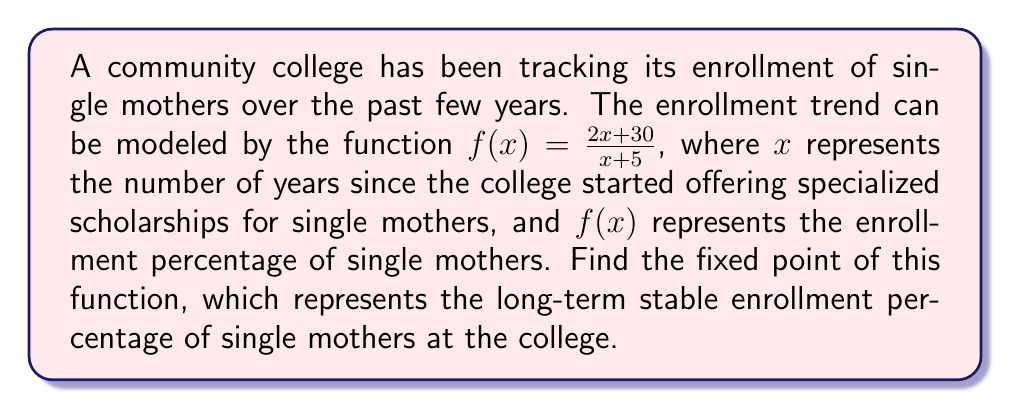Help me with this question. To find the fixed point of the function $f(x) = \frac{2x + 30}{x + 5}$, we need to solve the equation $f(x) = x$. This is because a fixed point is a value where the function's output equals its input.

1) Set up the equation:
   $$\frac{2x + 30}{x + 5} = x$$

2) Multiply both sides by $(x + 5)$:
   $$(2x + 30) = x(x + 5)$$

3) Expand the right side:
   $$(2x + 30) = x^2 + 5x$$

4) Subtract $2x$ and 30 from both sides:
   $$0 = x^2 + 3x - 30$$

5) This is a quadratic equation. We can solve it using the quadratic formula:
   $$x = \frac{-b \pm \sqrt{b^2 - 4ac}}{2a}$$
   where $a = 1$, $b = 3$, and $c = -30$

6) Substituting these values:
   $$x = \frac{-3 \pm \sqrt{3^2 - 4(1)(-30)}}{2(1)} = \frac{-3 \pm \sqrt{129}}{2}$$

7) Simplify:
   $$x = \frac{-3 \pm 11.36}{2}$$

8) This gives us two solutions:
   $$x_1 = \frac{-3 + 11.36}{2} = 4.18$$
   $$x_2 = \frac{-3 - 11.36}{2} = -7.18$$

9) Since we're dealing with enrollment percentages, negative values don't make sense in this context. Therefore, we only consider the positive solution.
Answer: The fixed point of the function is approximately 4.18 or 4.18%. 